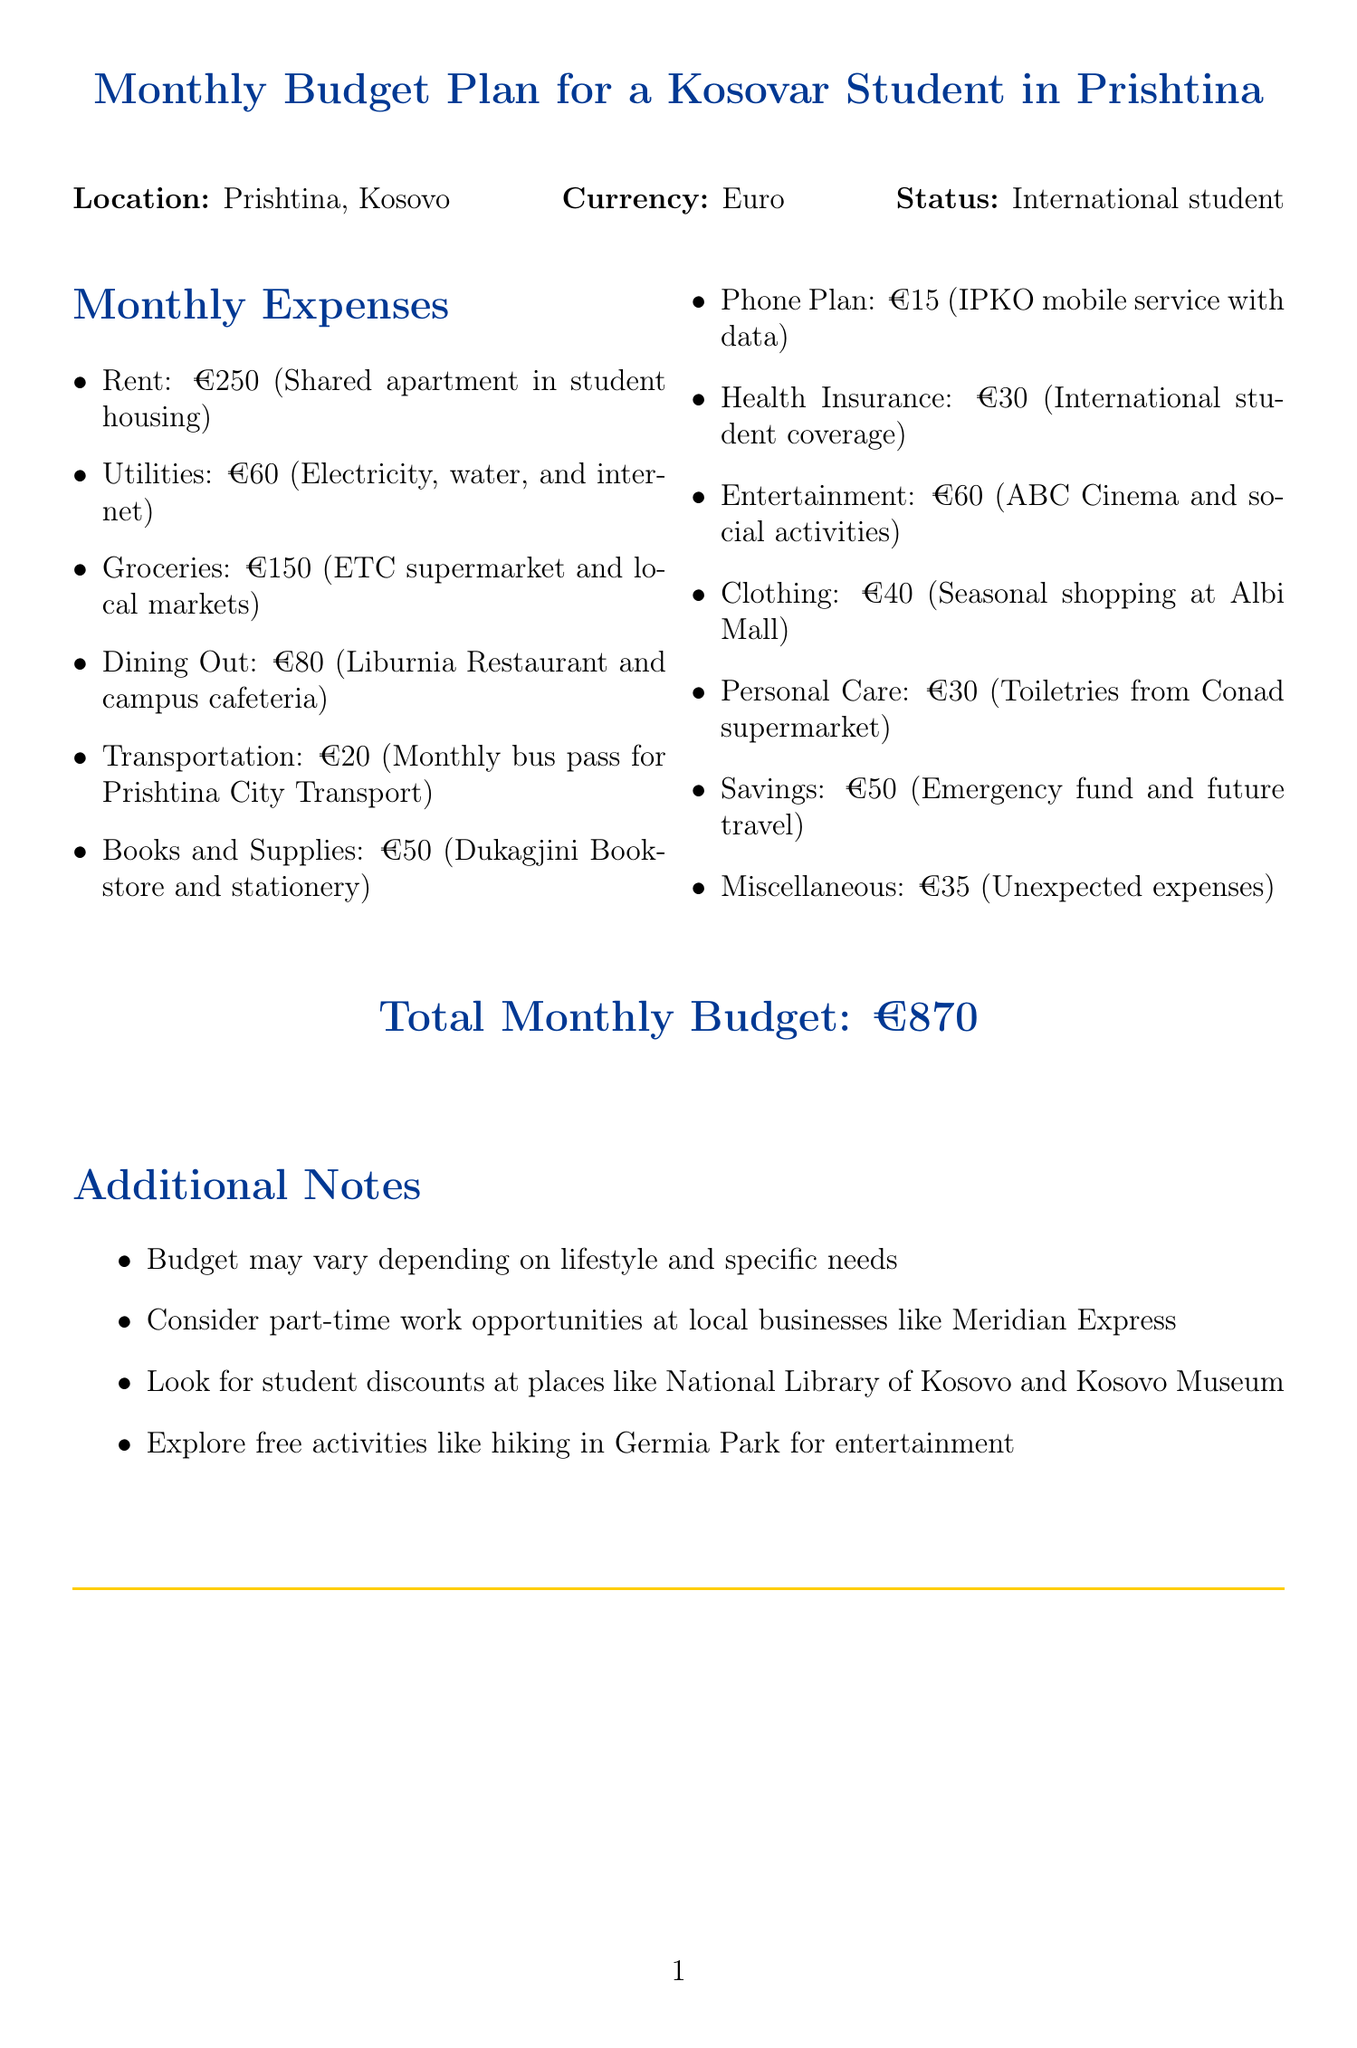What is the rent amount? The rent amount is specifically listed as €250 for the shared apartment.
Answer: €250 How much is allocated for groceries? The document specifies that the amount for groceries is €150, which is a separate expense.
Answer: €150 What is the total monthly budget? The total monthly budget is clearly stated in the document as €870.
Answer: €870 What category includes health coverage? Health Insurance is the category that includes international student health coverage.
Answer: Health Insurance What is the monthly cost for transportation? The transportation cost is identified as €20 for the monthly bus pass.
Answer: €20 Which expenses are included under personal care? Personal Care includes toiletries and hygiene products from Conad supermarket, as mentioned in the document.
Answer: Toiletries and hygiene products What amount is set aside for entertainment? The budget for entertainment is noted as €60 for activities like movies and social events.
Answer: €60 What additional consideration does the document suggest for work? The document suggests looking into part-time work opportunities at local businesses like Meridian Express.
Answer: Part-time work opportunities How much should be saved each month? The savings amount indicated in the budget is €50 intended for emergency funds and future travel.
Answer: €50 